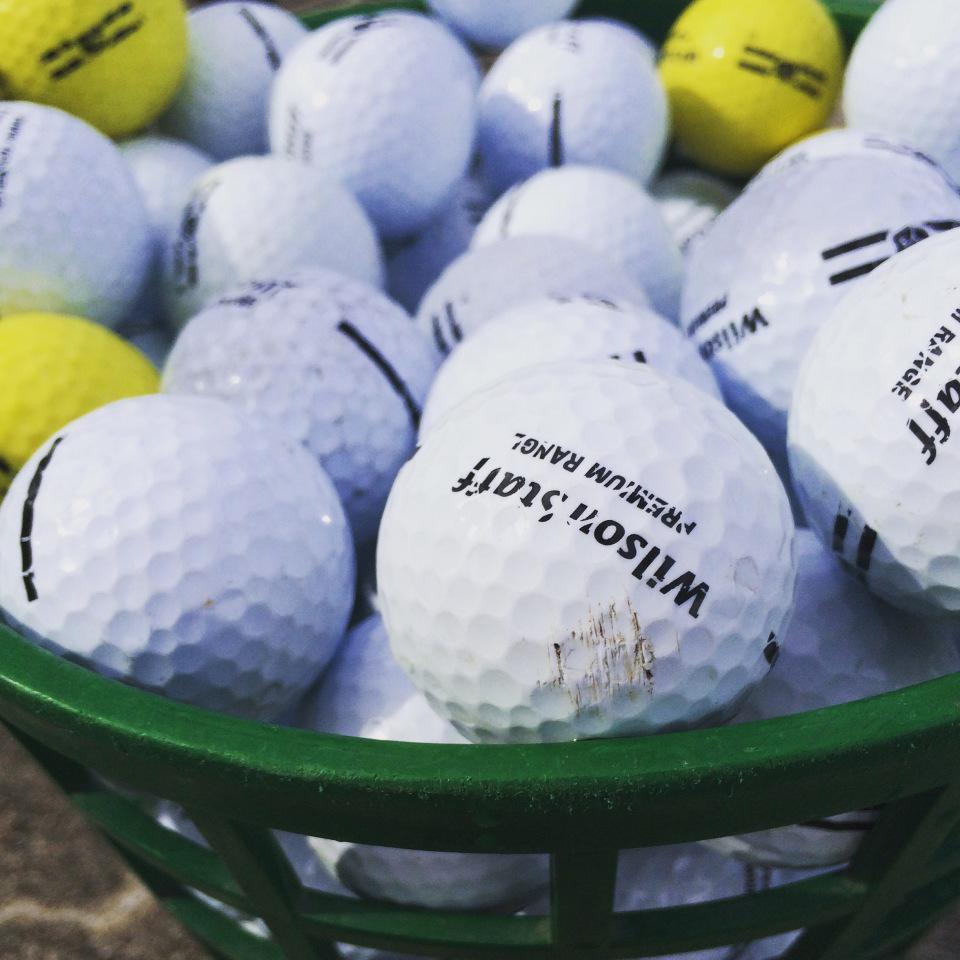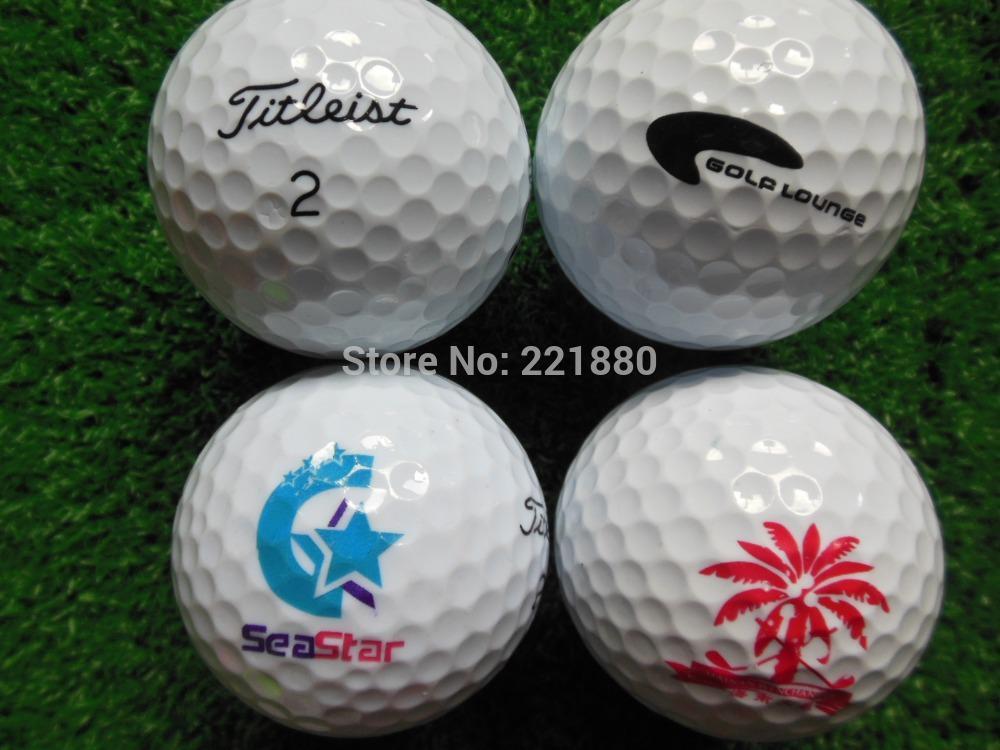The first image is the image on the left, the second image is the image on the right. For the images shown, is this caption "The balls in the image on the right are sitting in a green basket." true? Answer yes or no. No. The first image is the image on the left, the second image is the image on the right. Given the left and right images, does the statement "An image shows a green container filled with only white golf balls." hold true? Answer yes or no. No. 